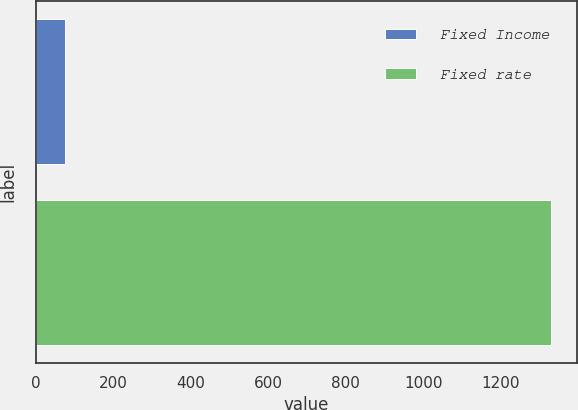<chart> <loc_0><loc_0><loc_500><loc_500><bar_chart><fcel>Fixed Income<fcel>Fixed rate<nl><fcel>76<fcel>1330<nl></chart> 